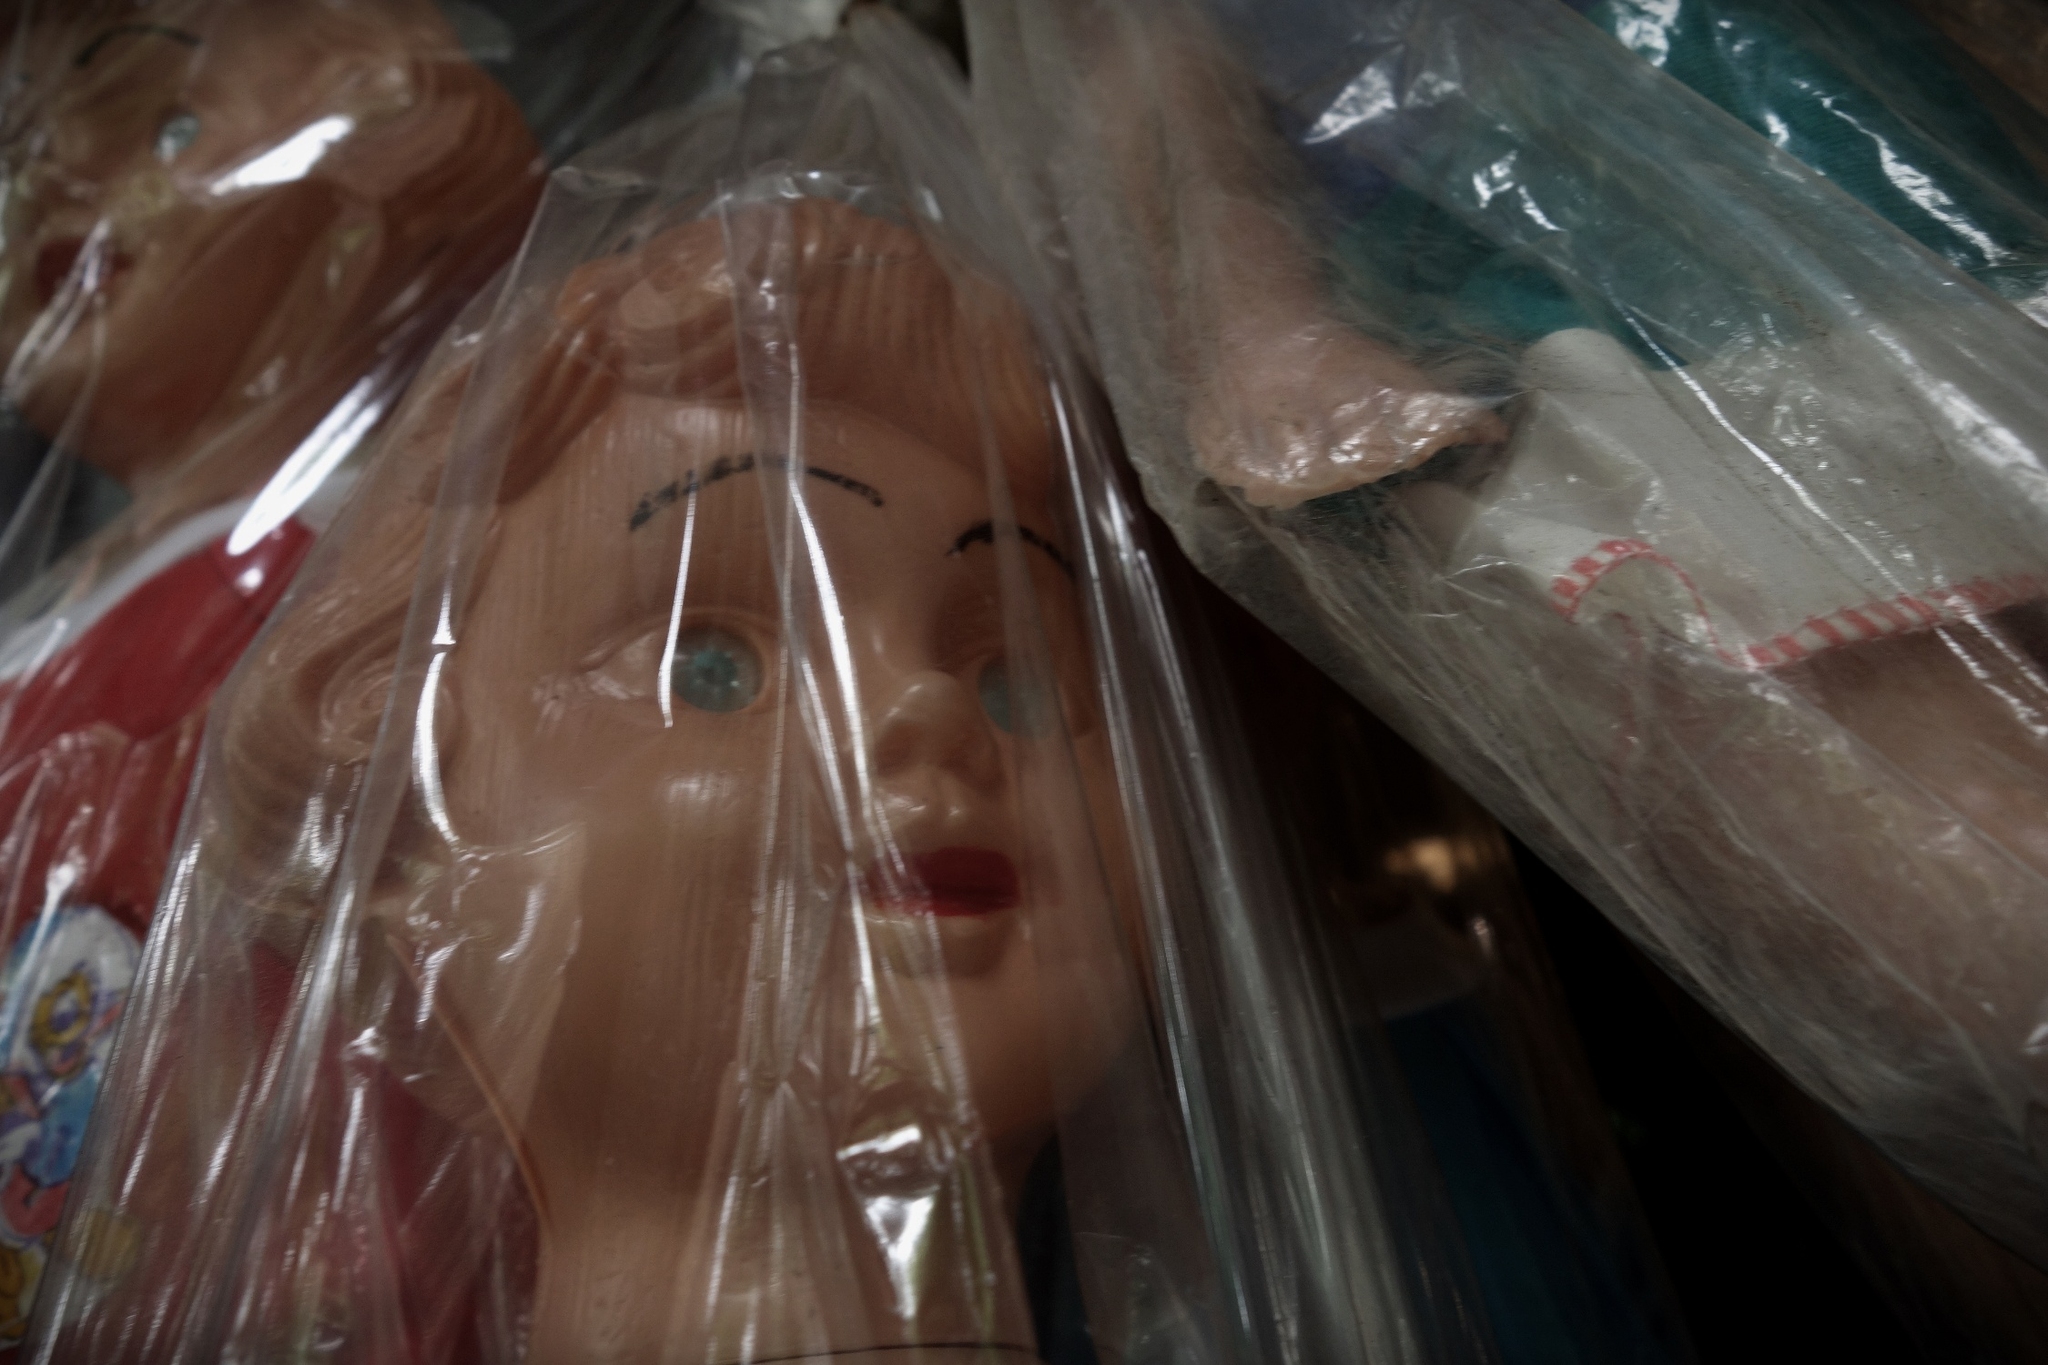What emotions does this image evoke? The image evokes a sense of nostalgia, as it conjures memories of childhood and the timeless act of playing with dolls. There is also a hint of melancholy, as the dolls are encased in plastic bags, suggesting they are no longer in active use but preserved as cherished keepsakes. 